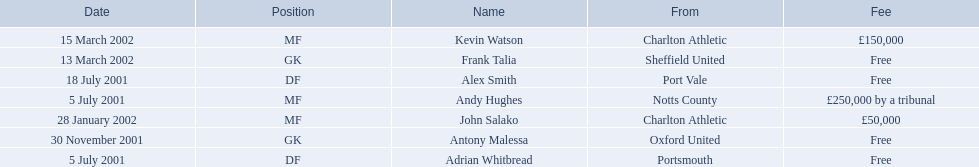Who were all the players? Andy Hughes, Adrian Whitbread, Alex Smith, Antony Malessa, John Salako, Frank Talia, Kevin Watson. What were the transfer fees of these players? £250,000 by a tribunal, Free, Free, Free, £50,000, Free, £150,000. Of these, which belong to andy hughes and john salako? £250,000 by a tribunal, £50,000. Of these, which is larger? £250,000 by a tribunal. Which player commanded this fee? Andy Hughes. 